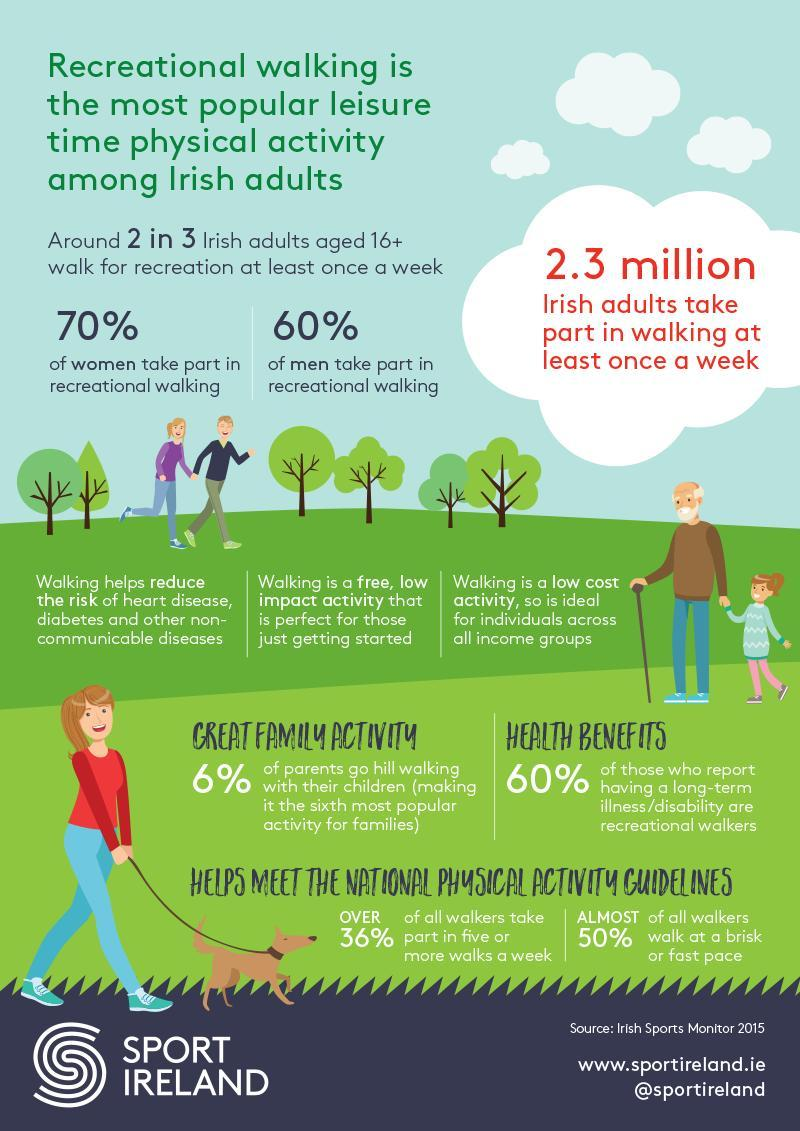What is the difference in percentage of women and men who take part in recreational walking ?
Answer the question with a short phrase. 10% 